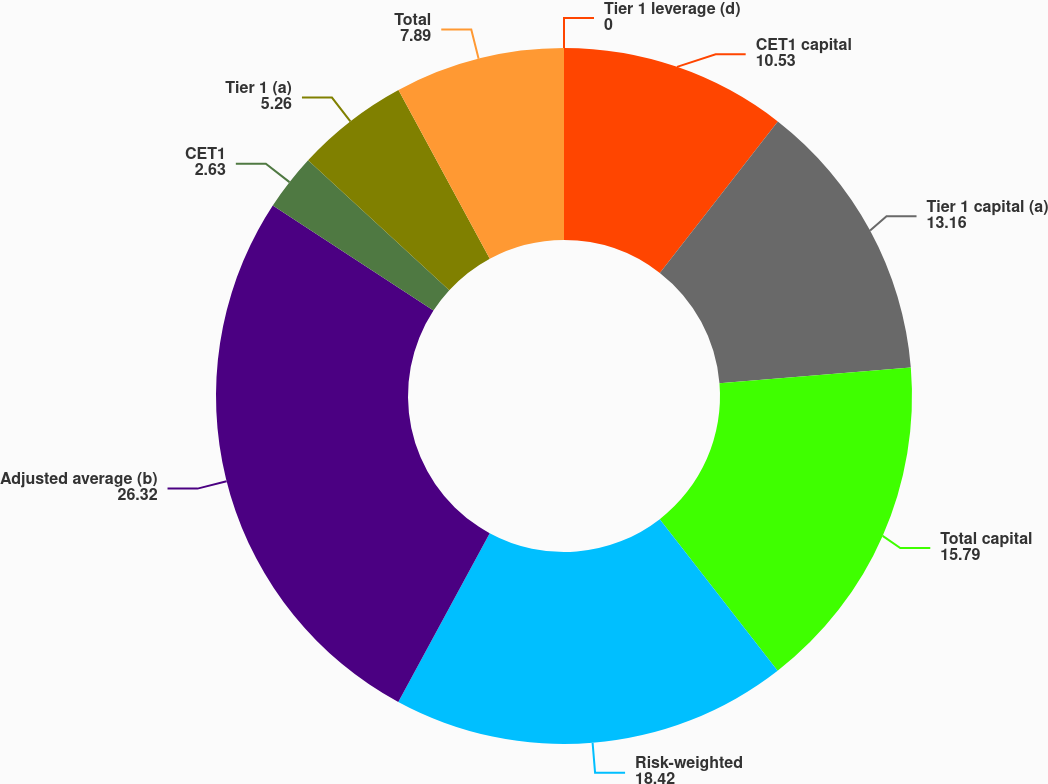<chart> <loc_0><loc_0><loc_500><loc_500><pie_chart><fcel>CET1 capital<fcel>Tier 1 capital (a)<fcel>Total capital<fcel>Risk-weighted<fcel>Adjusted average (b)<fcel>CET1<fcel>Tier 1 (a)<fcel>Total<fcel>Tier 1 leverage (d)<nl><fcel>10.53%<fcel>13.16%<fcel>15.79%<fcel>18.42%<fcel>26.32%<fcel>2.63%<fcel>5.26%<fcel>7.89%<fcel>0.0%<nl></chart> 